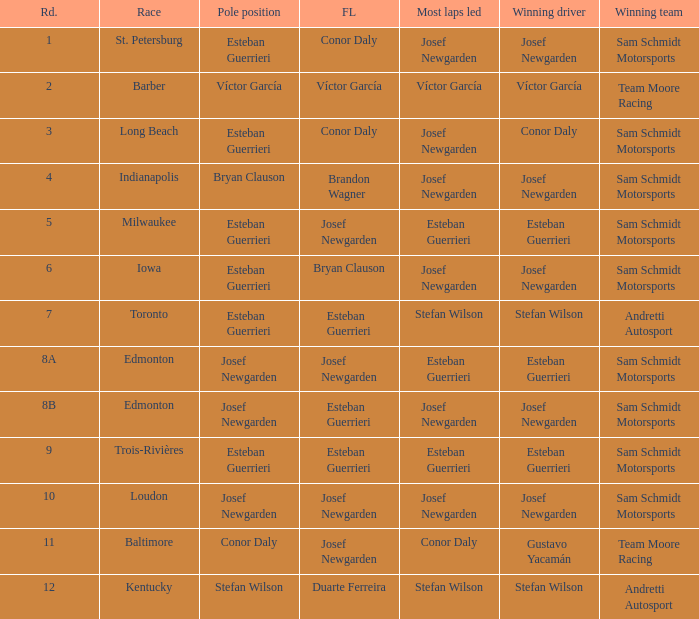Can you give me this table as a dict? {'header': ['Rd.', 'Race', 'Pole position', 'FL', 'Most laps led', 'Winning driver', 'Winning team'], 'rows': [['1', 'St. Petersburg', 'Esteban Guerrieri', 'Conor Daly', 'Josef Newgarden', 'Josef Newgarden', 'Sam Schmidt Motorsports'], ['2', 'Barber', 'Víctor García', 'Víctor García', 'Víctor García', 'Víctor García', 'Team Moore Racing'], ['3', 'Long Beach', 'Esteban Guerrieri', 'Conor Daly', 'Josef Newgarden', 'Conor Daly', 'Sam Schmidt Motorsports'], ['4', 'Indianapolis', 'Bryan Clauson', 'Brandon Wagner', 'Josef Newgarden', 'Josef Newgarden', 'Sam Schmidt Motorsports'], ['5', 'Milwaukee', 'Esteban Guerrieri', 'Josef Newgarden', 'Esteban Guerrieri', 'Esteban Guerrieri', 'Sam Schmidt Motorsports'], ['6', 'Iowa', 'Esteban Guerrieri', 'Bryan Clauson', 'Josef Newgarden', 'Josef Newgarden', 'Sam Schmidt Motorsports'], ['7', 'Toronto', 'Esteban Guerrieri', 'Esteban Guerrieri', 'Stefan Wilson', 'Stefan Wilson', 'Andretti Autosport'], ['8A', 'Edmonton', 'Josef Newgarden', 'Josef Newgarden', 'Esteban Guerrieri', 'Esteban Guerrieri', 'Sam Schmidt Motorsports'], ['8B', 'Edmonton', 'Josef Newgarden', 'Esteban Guerrieri', 'Josef Newgarden', 'Josef Newgarden', 'Sam Schmidt Motorsports'], ['9', 'Trois-Rivières', 'Esteban Guerrieri', 'Esteban Guerrieri', 'Esteban Guerrieri', 'Esteban Guerrieri', 'Sam Schmidt Motorsports'], ['10', 'Loudon', 'Josef Newgarden', 'Josef Newgarden', 'Josef Newgarden', 'Josef Newgarden', 'Sam Schmidt Motorsports'], ['11', 'Baltimore', 'Conor Daly', 'Josef Newgarden', 'Conor Daly', 'Gustavo Yacamán', 'Team Moore Racing'], ['12', 'Kentucky', 'Stefan Wilson', 'Duarte Ferreira', 'Stefan Wilson', 'Stefan Wilson', 'Andretti Autosport']]} Who led the most laps when brandon wagner had the fastest lap? Josef Newgarden. 